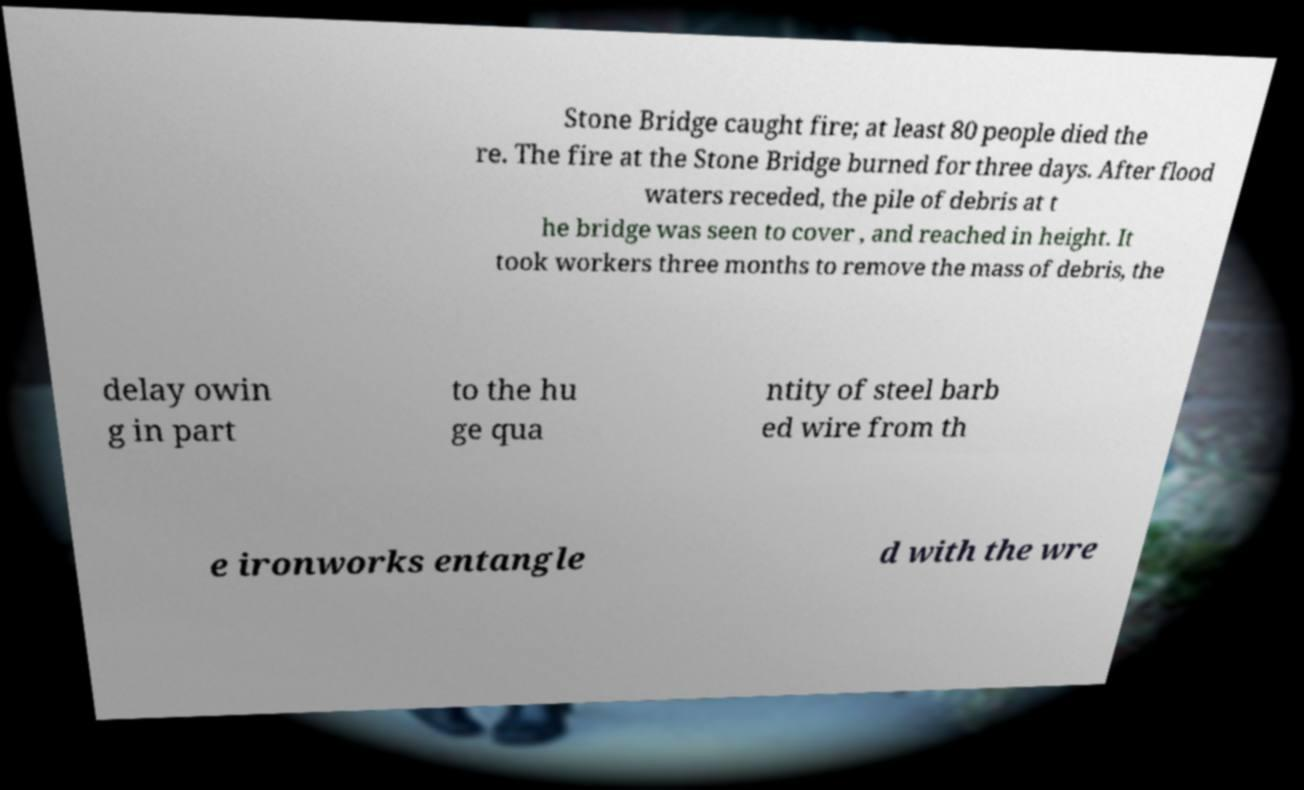Could you extract and type out the text from this image? Stone Bridge caught fire; at least 80 people died the re. The fire at the Stone Bridge burned for three days. After flood waters receded, the pile of debris at t he bridge was seen to cover , and reached in height. It took workers three months to remove the mass of debris, the delay owin g in part to the hu ge qua ntity of steel barb ed wire from th e ironworks entangle d with the wre 